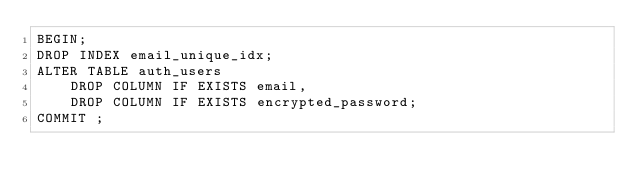<code> <loc_0><loc_0><loc_500><loc_500><_SQL_>BEGIN;
DROP INDEX email_unique_idx;
ALTER TABLE auth_users
    DROP COLUMN IF EXISTS email,
    DROP COLUMN IF EXISTS encrypted_password;
COMMIT ;
</code> 